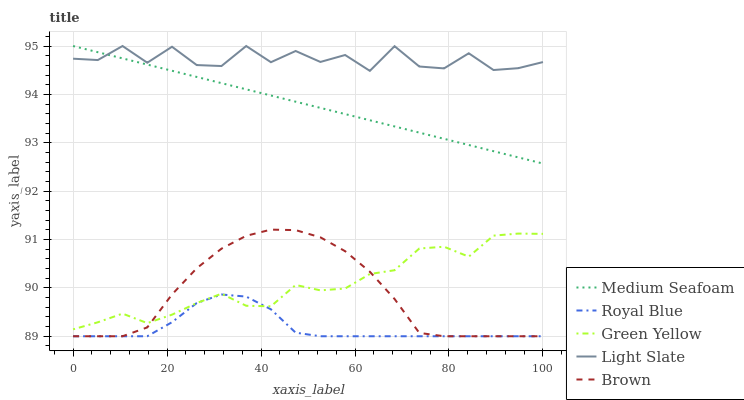Does Royal Blue have the minimum area under the curve?
Answer yes or no. Yes. Does Light Slate have the maximum area under the curve?
Answer yes or no. Yes. Does Green Yellow have the minimum area under the curve?
Answer yes or no. No. Does Green Yellow have the maximum area under the curve?
Answer yes or no. No. Is Medium Seafoam the smoothest?
Answer yes or no. Yes. Is Light Slate the roughest?
Answer yes or no. Yes. Is Royal Blue the smoothest?
Answer yes or no. No. Is Royal Blue the roughest?
Answer yes or no. No. Does Green Yellow have the lowest value?
Answer yes or no. No. Does Green Yellow have the highest value?
Answer yes or no. No. Is Green Yellow less than Medium Seafoam?
Answer yes or no. Yes. Is Medium Seafoam greater than Brown?
Answer yes or no. Yes. Does Green Yellow intersect Medium Seafoam?
Answer yes or no. No. 